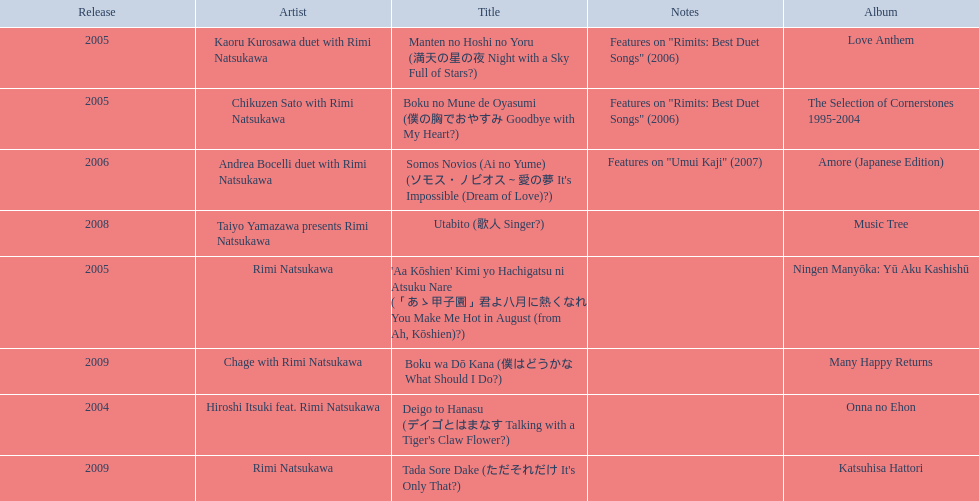How many titles have only one artist? 2. 